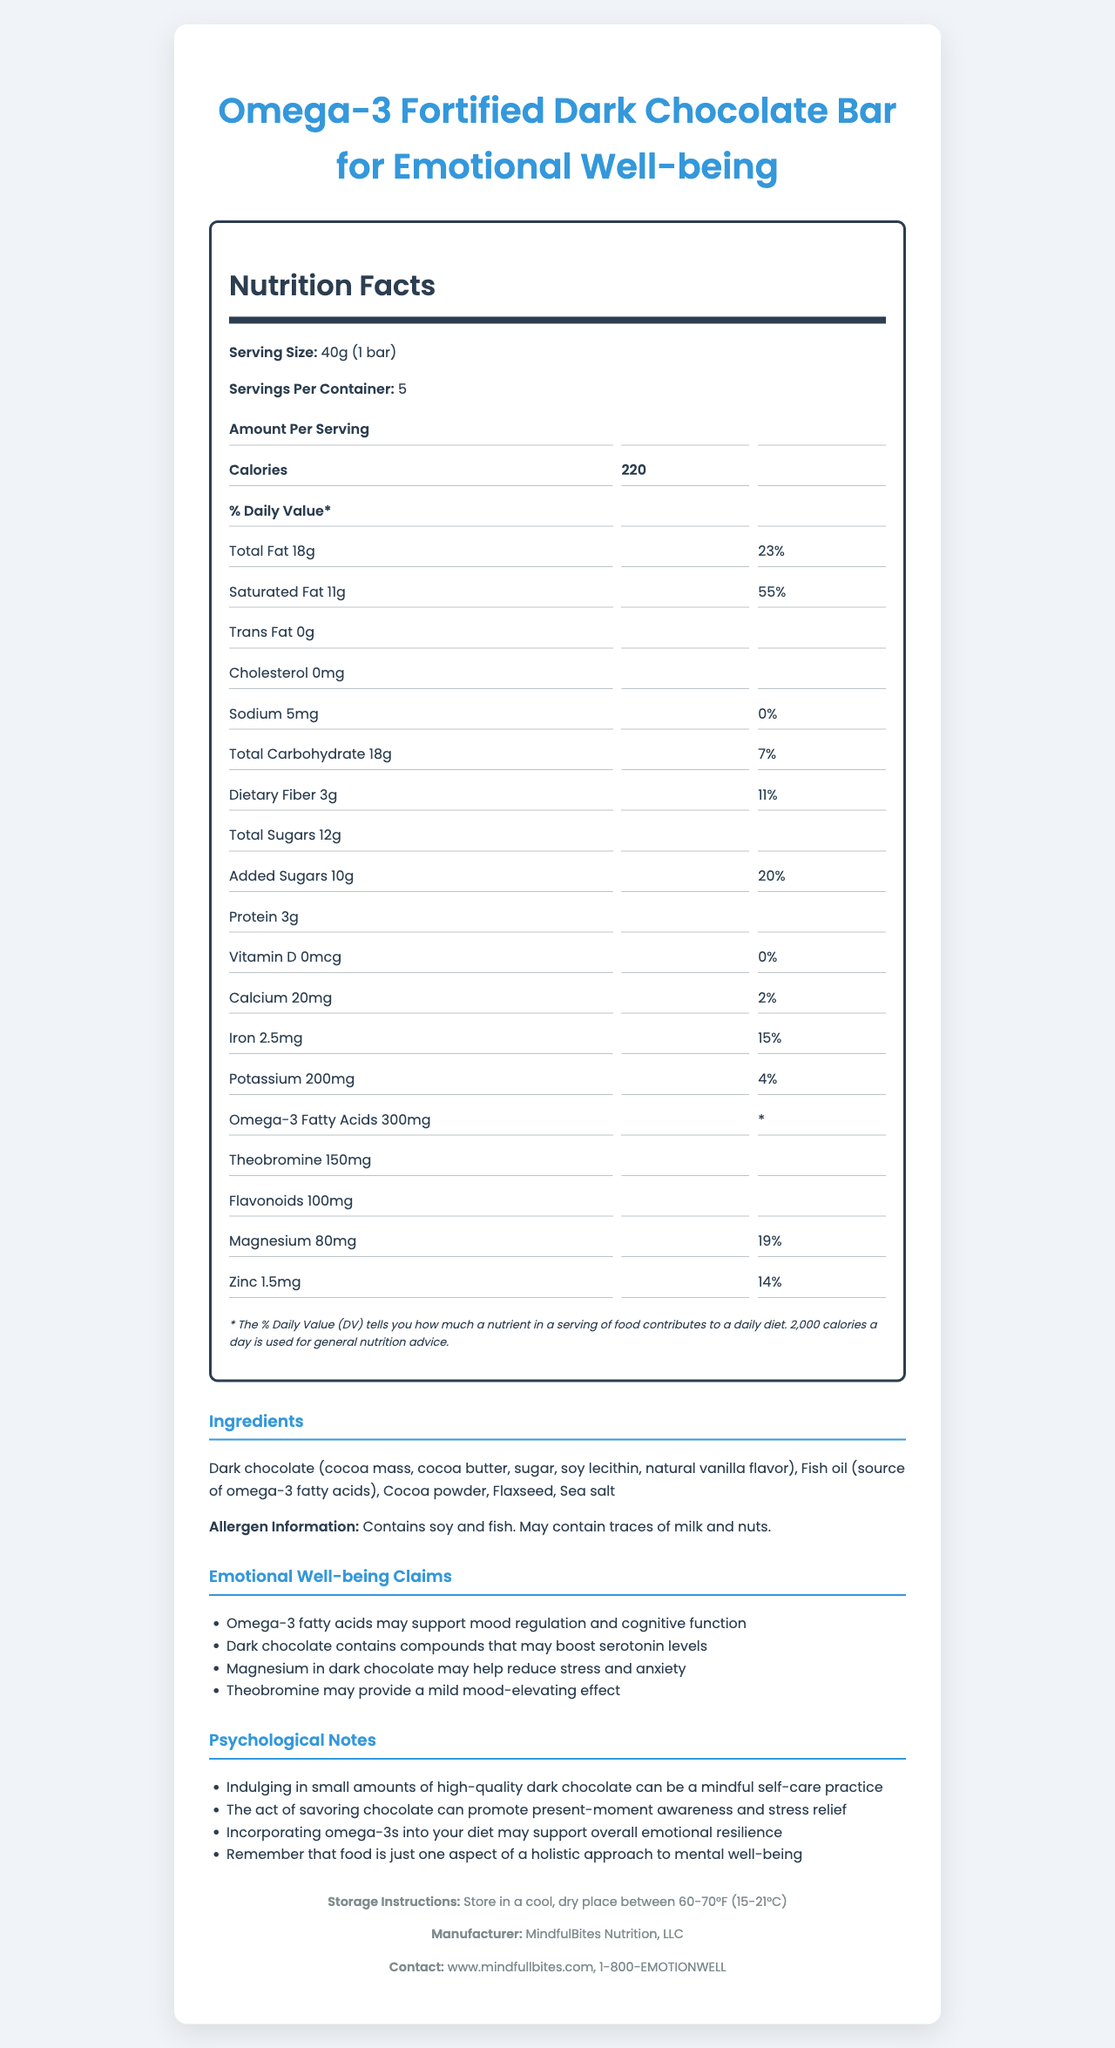what is the serving size? The serving size is explicitly stated as "40g (1 bar)" at the beginning of the nutrition label.
Answer: 40g (1 bar) what are the emotional well-being claims made by this product? These claims are listed under the "Emotional Well-being Claims" section of the document.
Answer: Omega-3 fatty acids may support mood regulation and cognitive function; Dark chocolate contains compounds that may boost serotonin levels; Magnesium in dark chocolate may help reduce stress and anxiety; Theobromine may provide a mild mood-elevating effect how many servings are there per container? The document states "Servings Per Container: 5" under the nutrition label.
Answer: 5 what allergen information is provided? The allergen information is listed under the "Ingredients" section, which states "Contains soy and fish. May contain traces of milk and nuts."
Answer: Contains soy and fish. May contain traces of milk and nuts. how much protein is there per serving? According to the nutrition facts, the amount of protein per serving is 3g.
Answer: 3g how many calories does each serving contain? The document states "Calories: 220" under the "Nutrition Facts" section.
Answer: 220 what is the daily value percentage of saturated fat? The nutrition facts show that the daily value percentage for saturated fat is 55%.
Answer: 55% how much magnesium does a serving contain? A. 50mg B. 80mg C. 100mg The document lists that magnesium content per serving is 80mg.
Answer: B which ingredient is a source of omega-3 fatty acids? A. Dark chocolate B. Fish oil C. Flaxseed The document lists fish oil as the source of omega-3 fatty acids under the "Ingredients" section.
Answer: B is this product safe for individuals allergic to fish? The allergen information section explicitly states that the product contains fish, thus it is not safe for individuals with a fish allergy.
Answer: No does this product contain any trans fat? The nutrition facts state that the product contains "0g" of trans fat.
Answer: No summarize the main idea of the document. The document serves to inform consumers about the nutritional content, emotional benefits, ingredients, and other pertinent product details of the dark chocolate bar.
Answer: This document provides the nutritional information, emotional well-being claims, psychological notes, and ingredient details for the "Omega-3 Fortified Dark Chocolate Bar for Emotional Well-being." The product aims to support mood regulation and cognitive function through the inclusion of omega-3 fatty acids, magnesium, and other compounds in dark chocolate. The document also includes allergen information, storage instructions, and manufacturer contact details. what are the psychological notes mentioned in the document? These notes are listed under the "Psychological Notes" section, providing insights into how the product can be used for emotional well-being.
Answer: Indulging in small amounts of high-quality dark chocolate can be a mindful self-care practice; The act of savoring chocolate can promote present-moment awareness and stress relief; Incorporating omega-3s into your diet may support overall emotional resilience; Remember that food is just one aspect of a holistic approach to mental well-being how much added sugar does each serving contain? According to the nutrition facts, the amount of added sugars per serving is 10g.
Answer: 10g can the exact amount of theobromine and flavonoids in the product be determined based on the daily values? While the amounts for theobromine (150mg) and flavonoids (100mg) are given, daily values for these compounds are not provided, making it impossible to determine their percentages.
Answer: Not enough information 